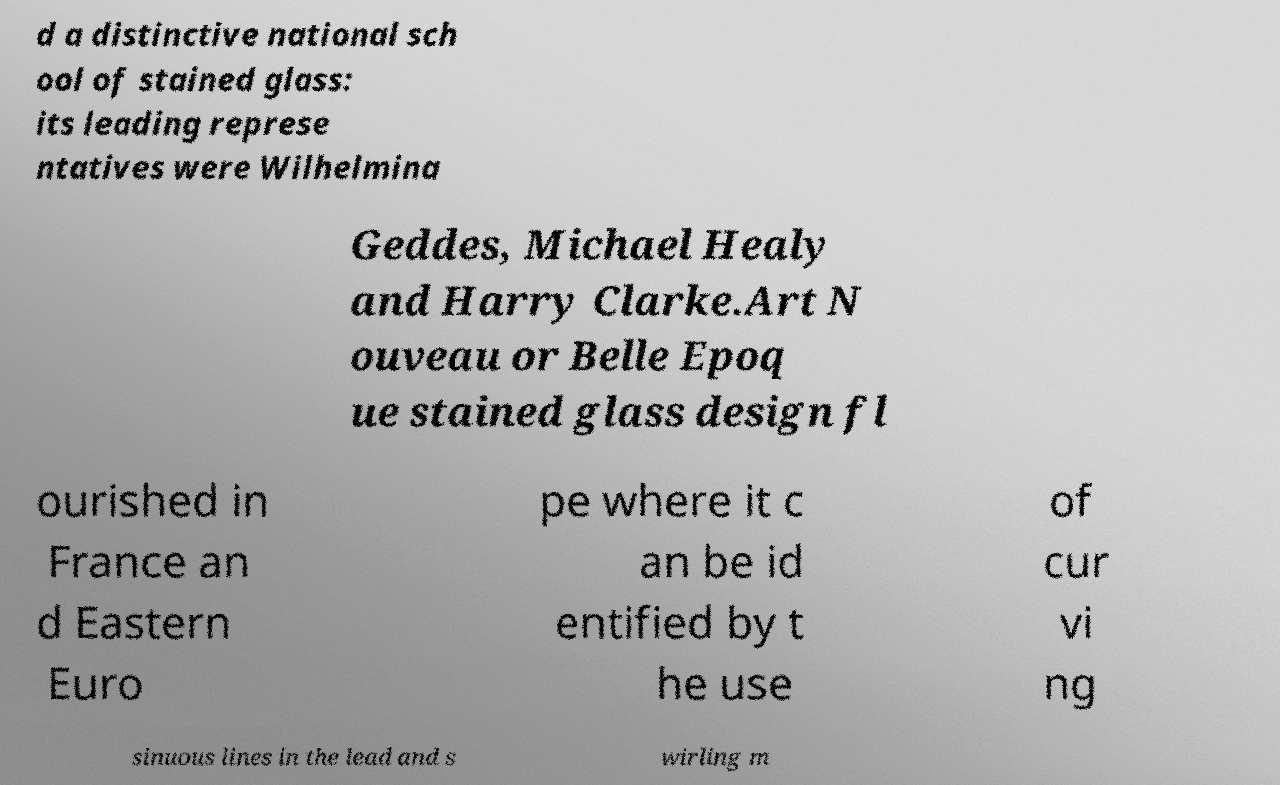Can you read and provide the text displayed in the image?This photo seems to have some interesting text. Can you extract and type it out for me? d a distinctive national sch ool of stained glass: its leading represe ntatives were Wilhelmina Geddes, Michael Healy and Harry Clarke.Art N ouveau or Belle Epoq ue stained glass design fl ourished in France an d Eastern Euro pe where it c an be id entified by t he use of cur vi ng sinuous lines in the lead and s wirling m 